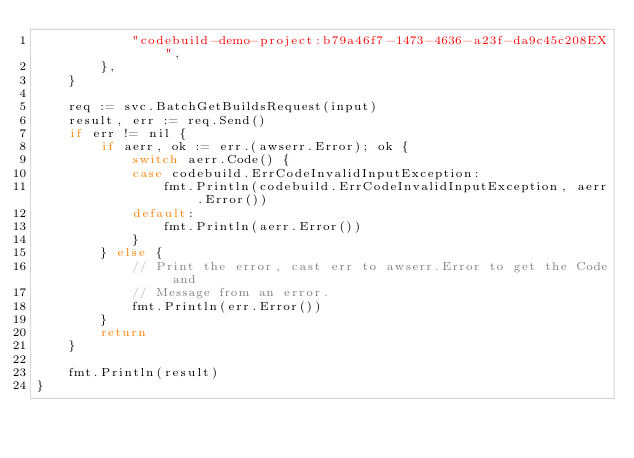Convert code to text. <code><loc_0><loc_0><loc_500><loc_500><_Go_>			"codebuild-demo-project:b79a46f7-1473-4636-a23f-da9c45c208EX",
		},
	}

	req := svc.BatchGetBuildsRequest(input)
	result, err := req.Send()
	if err != nil {
		if aerr, ok := err.(awserr.Error); ok {
			switch aerr.Code() {
			case codebuild.ErrCodeInvalidInputException:
				fmt.Println(codebuild.ErrCodeInvalidInputException, aerr.Error())
			default:
				fmt.Println(aerr.Error())
			}
		} else {
			// Print the error, cast err to awserr.Error to get the Code and
			// Message from an error.
			fmt.Println(err.Error())
		}
		return
	}

	fmt.Println(result)
}
</code> 